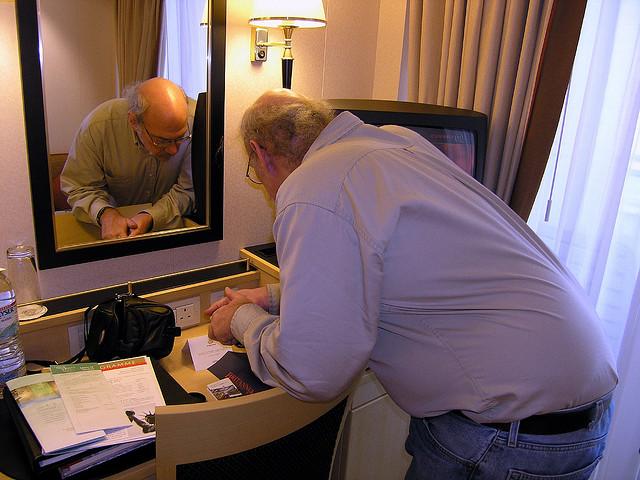Is this hairstyle easy to do?
Answer briefly. Yes. Is the man looking at himself in the mirror?
Be succinct. No. Are there papers on the desk?
Give a very brief answer. Yes. What is the man looking for?
Give a very brief answer. Pen. What type of book is likely being used by the man?
Answer briefly. Menu. What room is the man in?
Short answer required. Bedroom. Where are gray squares?
Quick response, please. Nowhere. 